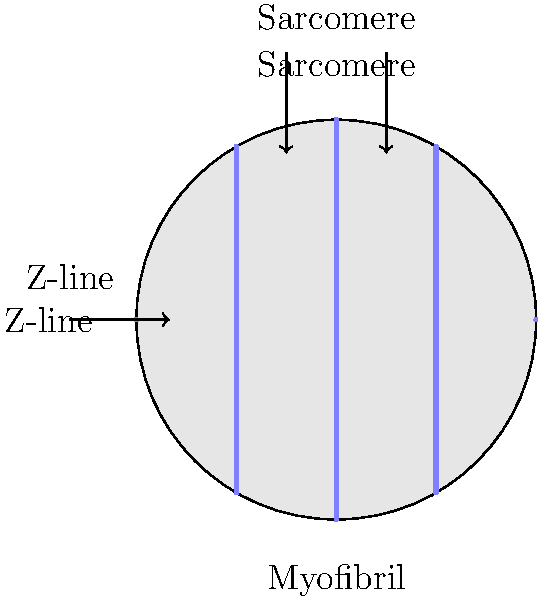In the simplified cross-sectional diagram of a skeletal muscle fiber shown above, what is the name of the repeating functional unit of the myofibril, marked by the distance between two adjacent Z-lines? To answer this question, let's break down the structure of a skeletal muscle fiber:

1. The diagram shows a cross-section of a skeletal muscle fiber.
2. Within the muscle fiber, we can see smaller structures called myofibrils.
3. Myofibrils are composed of repeating units that give muscles their striated appearance.
4. These repeating units are bounded by dark lines called Z-lines (or Z-discs).
5. The region between two adjacent Z-lines is the fundamental functional unit of the muscle fiber.
6. This unit is called a sarcomere.
7. Sarcomeres contain the contractile proteins (actin and myosin) that enable muscle contraction.
8. In the diagram, the sarcomere is clearly labeled and indicated by the arrows pointing to the region between two Z-lines.

Therefore, the repeating functional unit of the myofibril, marked by the distance between two adjacent Z-lines, is the sarcomere.
Answer: Sarcomere 